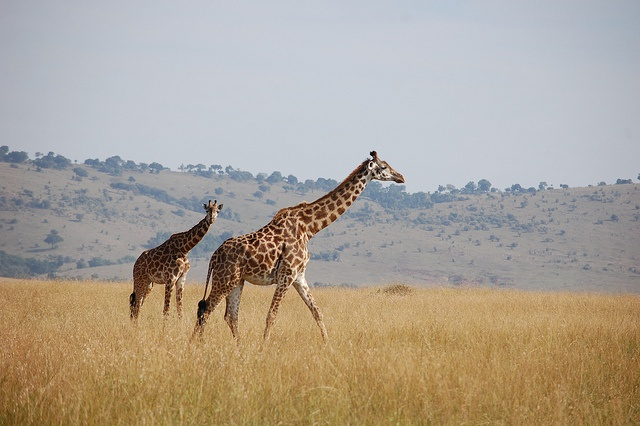Describe the objects in this image and their specific colors. I can see a giraffe in darkgray, maroon, black, and gray tones in this image. 